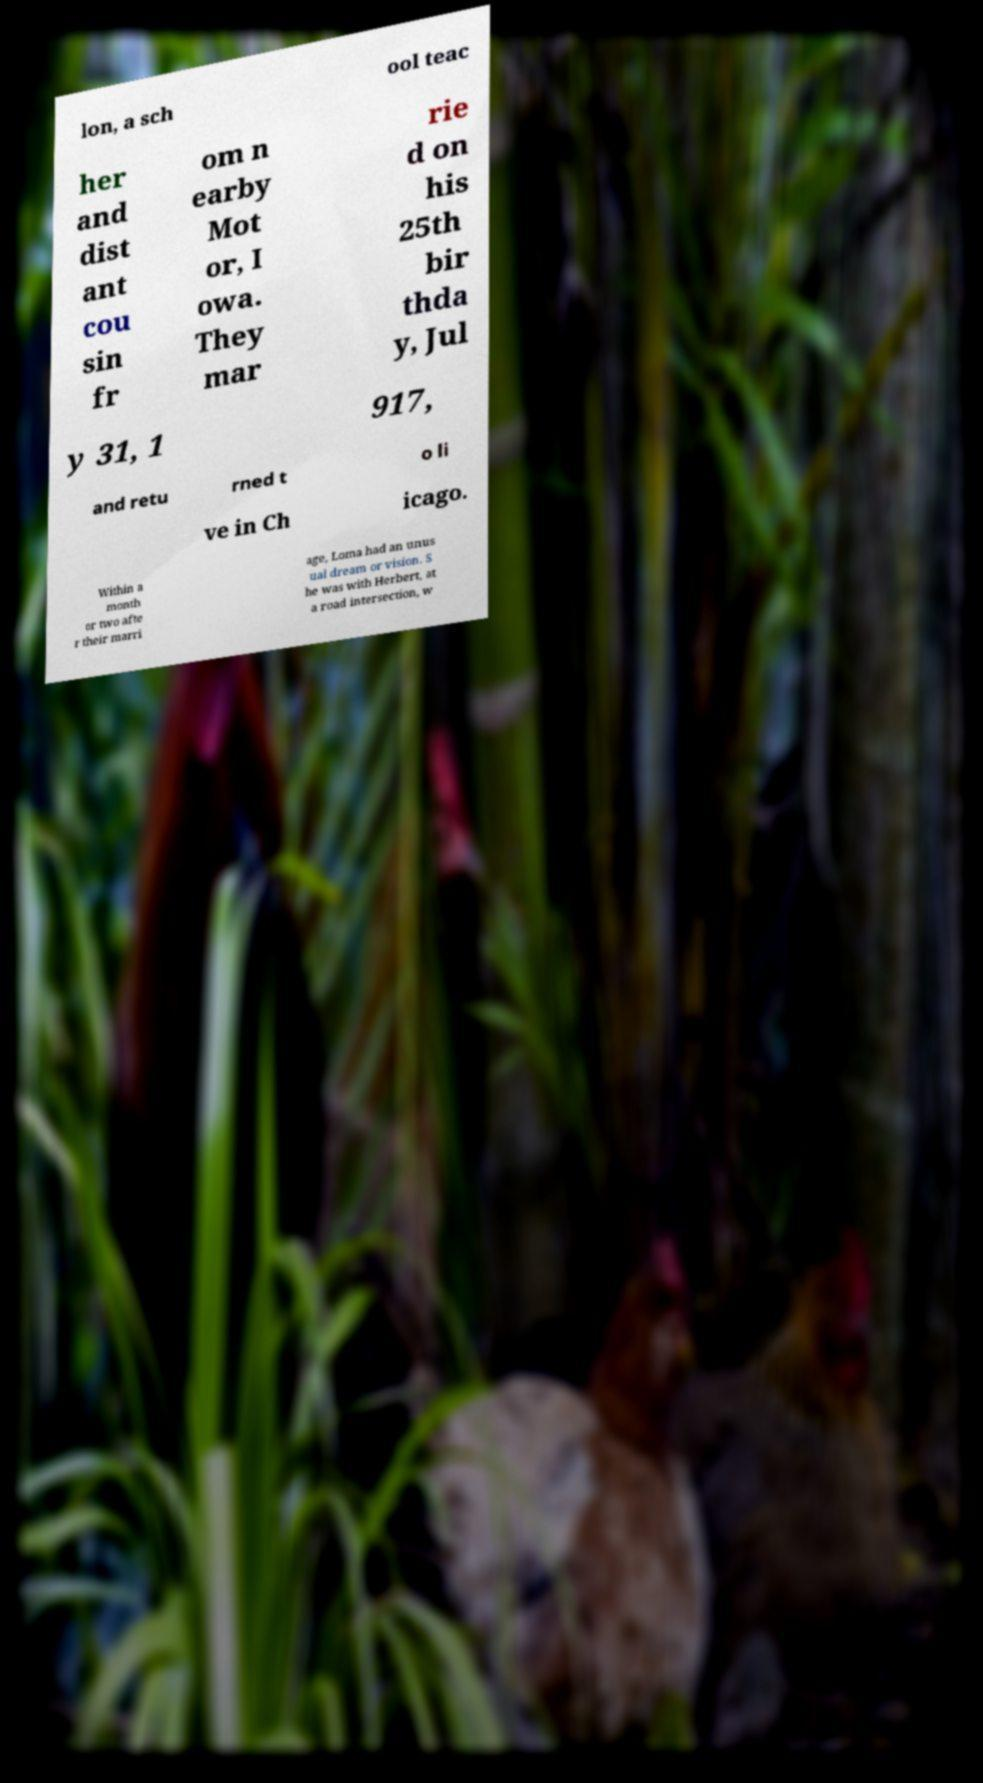Could you assist in decoding the text presented in this image and type it out clearly? lon, a sch ool teac her and dist ant cou sin fr om n earby Mot or, I owa. They mar rie d on his 25th bir thda y, Jul y 31, 1 917, and retu rned t o li ve in Ch icago. Within a month or two afte r their marri age, Loma had an unus ual dream or vision. S he was with Herbert, at a road intersection, w 